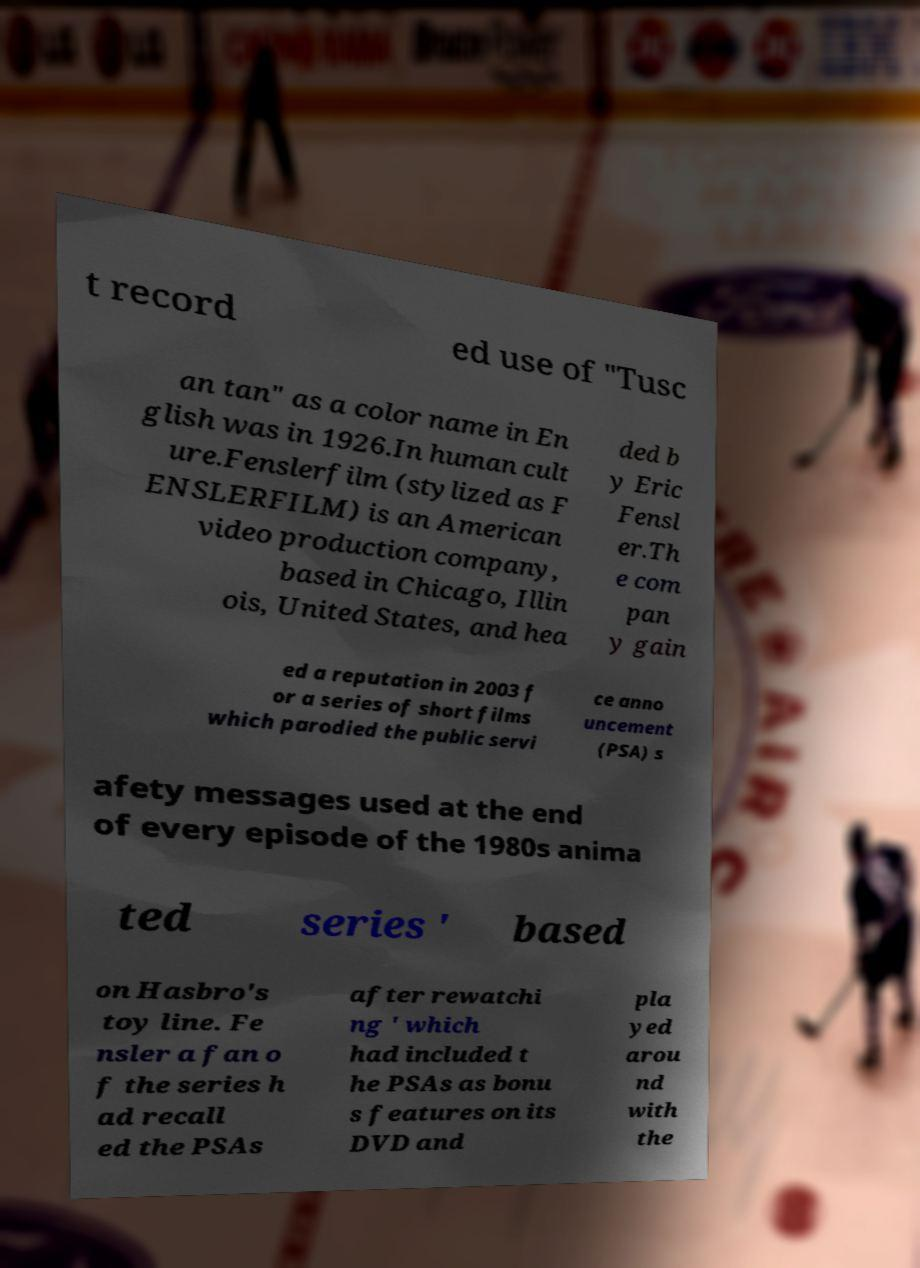Please identify and transcribe the text found in this image. t record ed use of "Tusc an tan" as a color name in En glish was in 1926.In human cult ure.Fenslerfilm (stylized as F ENSLERFILM) is an American video production company, based in Chicago, Illin ois, United States, and hea ded b y Eric Fensl er.Th e com pan y gain ed a reputation in 2003 f or a series of short films which parodied the public servi ce anno uncement (PSA) s afety messages used at the end of every episode of the 1980s anima ted series ' based on Hasbro's toy line. Fe nsler a fan o f the series h ad recall ed the PSAs after rewatchi ng ' which had included t he PSAs as bonu s features on its DVD and pla yed arou nd with the 